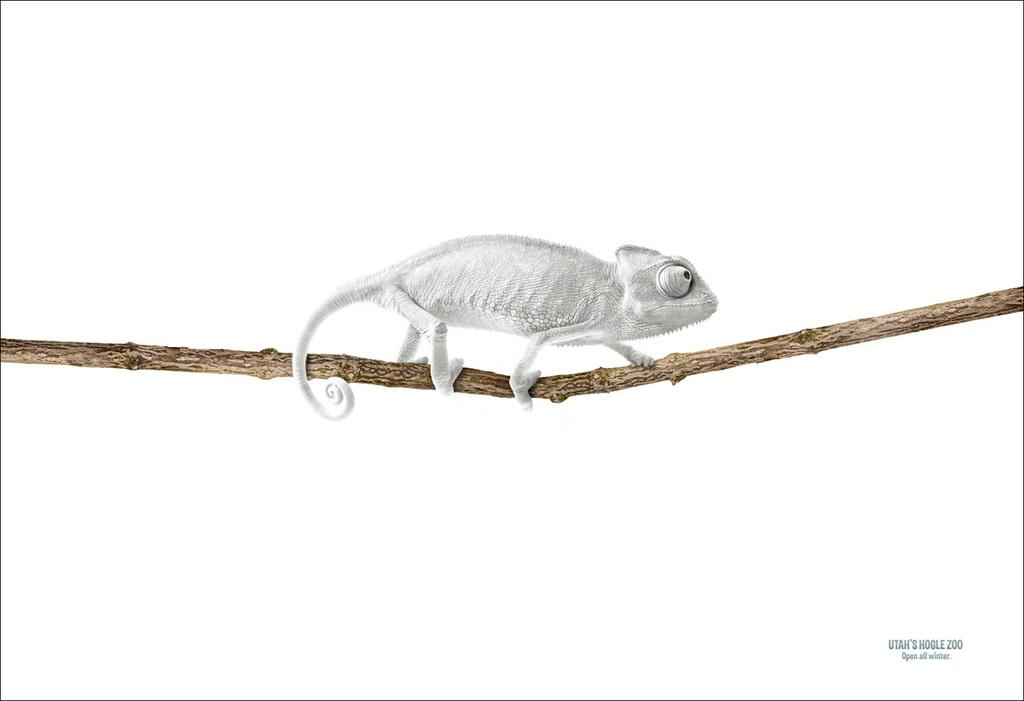What object can be seen in the image that is made of wood? There is a wooden stick in the image. What is attached to the wooden stick? There is a toy of an animal on the wooden stick. Can you tell me how much cheese is on the wooden stick in the image? There is no cheese present in the image; it features a wooden stick with a toy of an animal attached to it. 